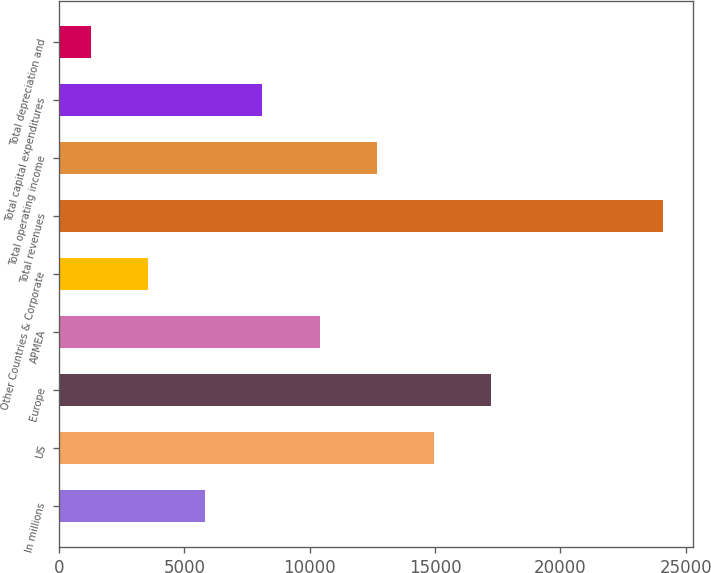Convert chart. <chart><loc_0><loc_0><loc_500><loc_500><bar_chart><fcel>In millions<fcel>US<fcel>Europe<fcel>APMEA<fcel>Other Countries & Corporate<fcel>Total revenues<fcel>Total operating income<fcel>Total capital expenditures<fcel>Total depreciation and<nl><fcel>5835.88<fcel>14955.2<fcel>17235.1<fcel>10395.6<fcel>3556.04<fcel>24074.6<fcel>12675.4<fcel>8115.72<fcel>1276.2<nl></chart> 